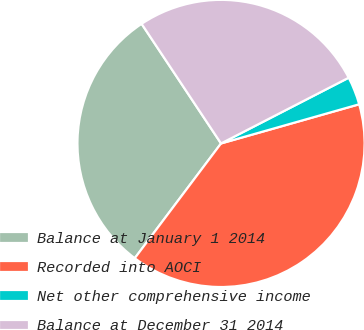Convert chart. <chart><loc_0><loc_0><loc_500><loc_500><pie_chart><fcel>Balance at January 1 2014<fcel>Recorded into AOCI<fcel>Net other comprehensive income<fcel>Balance at December 31 2014<nl><fcel>30.41%<fcel>39.65%<fcel>3.17%<fcel>26.76%<nl></chart> 